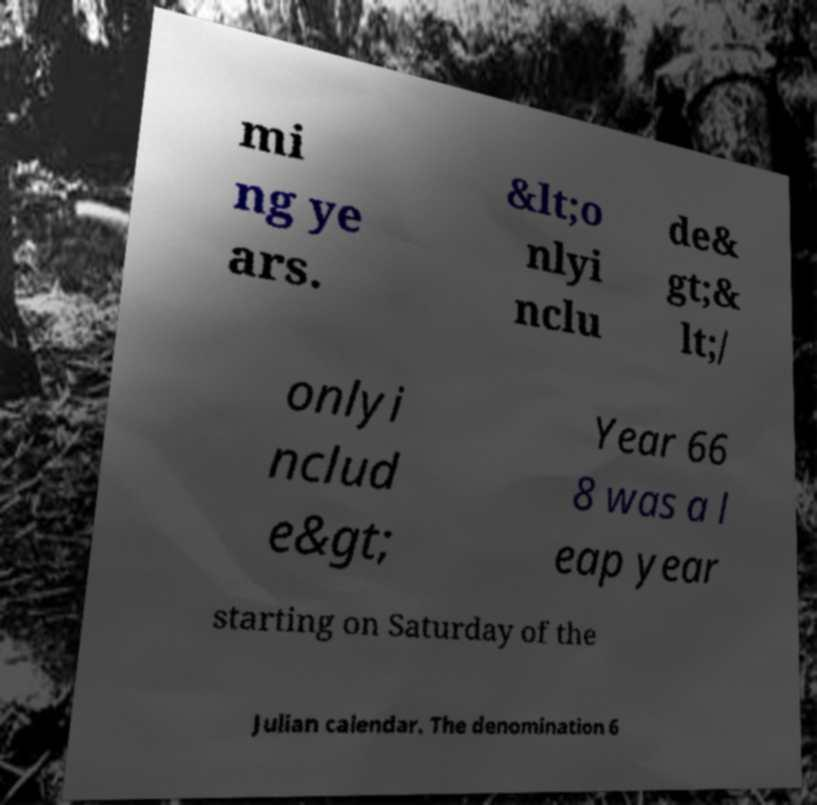Please read and relay the text visible in this image. What does it say? mi ng ye ars. &lt;o nlyi nclu de& gt;& lt;/ onlyi nclud e&gt; Year 66 8 was a l eap year starting on Saturday of the Julian calendar. The denomination 6 